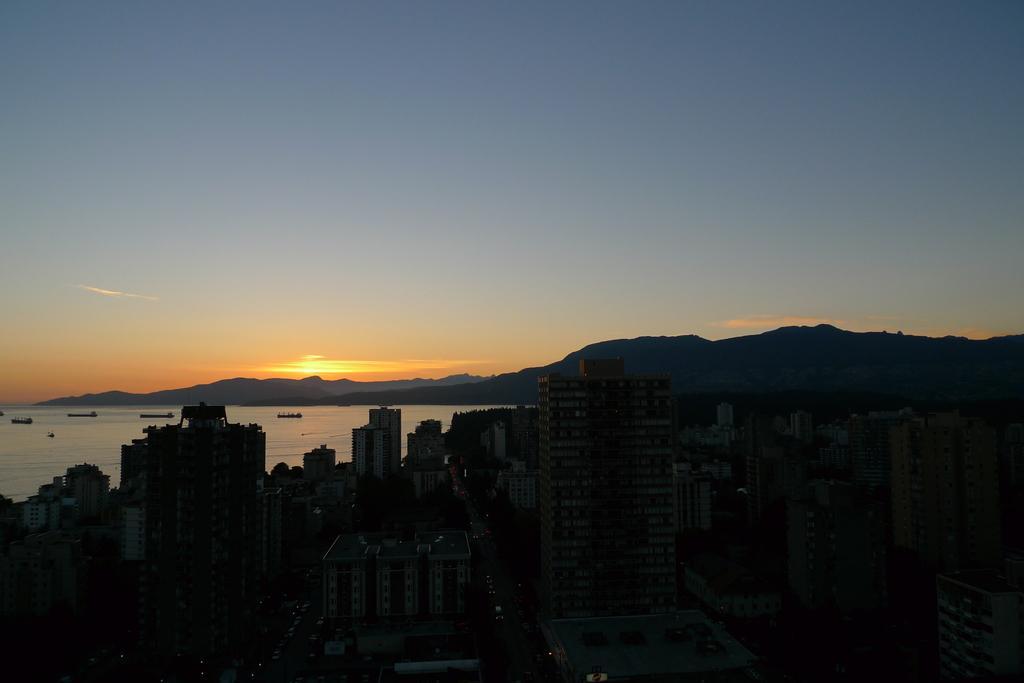Can you describe this image briefly? This is an outside view. At the bottom of the image I can see the buildings. On the left side there is a sea and I can see few boats on the water. In the background there are few hills. At the top of the image I can see the sky. 